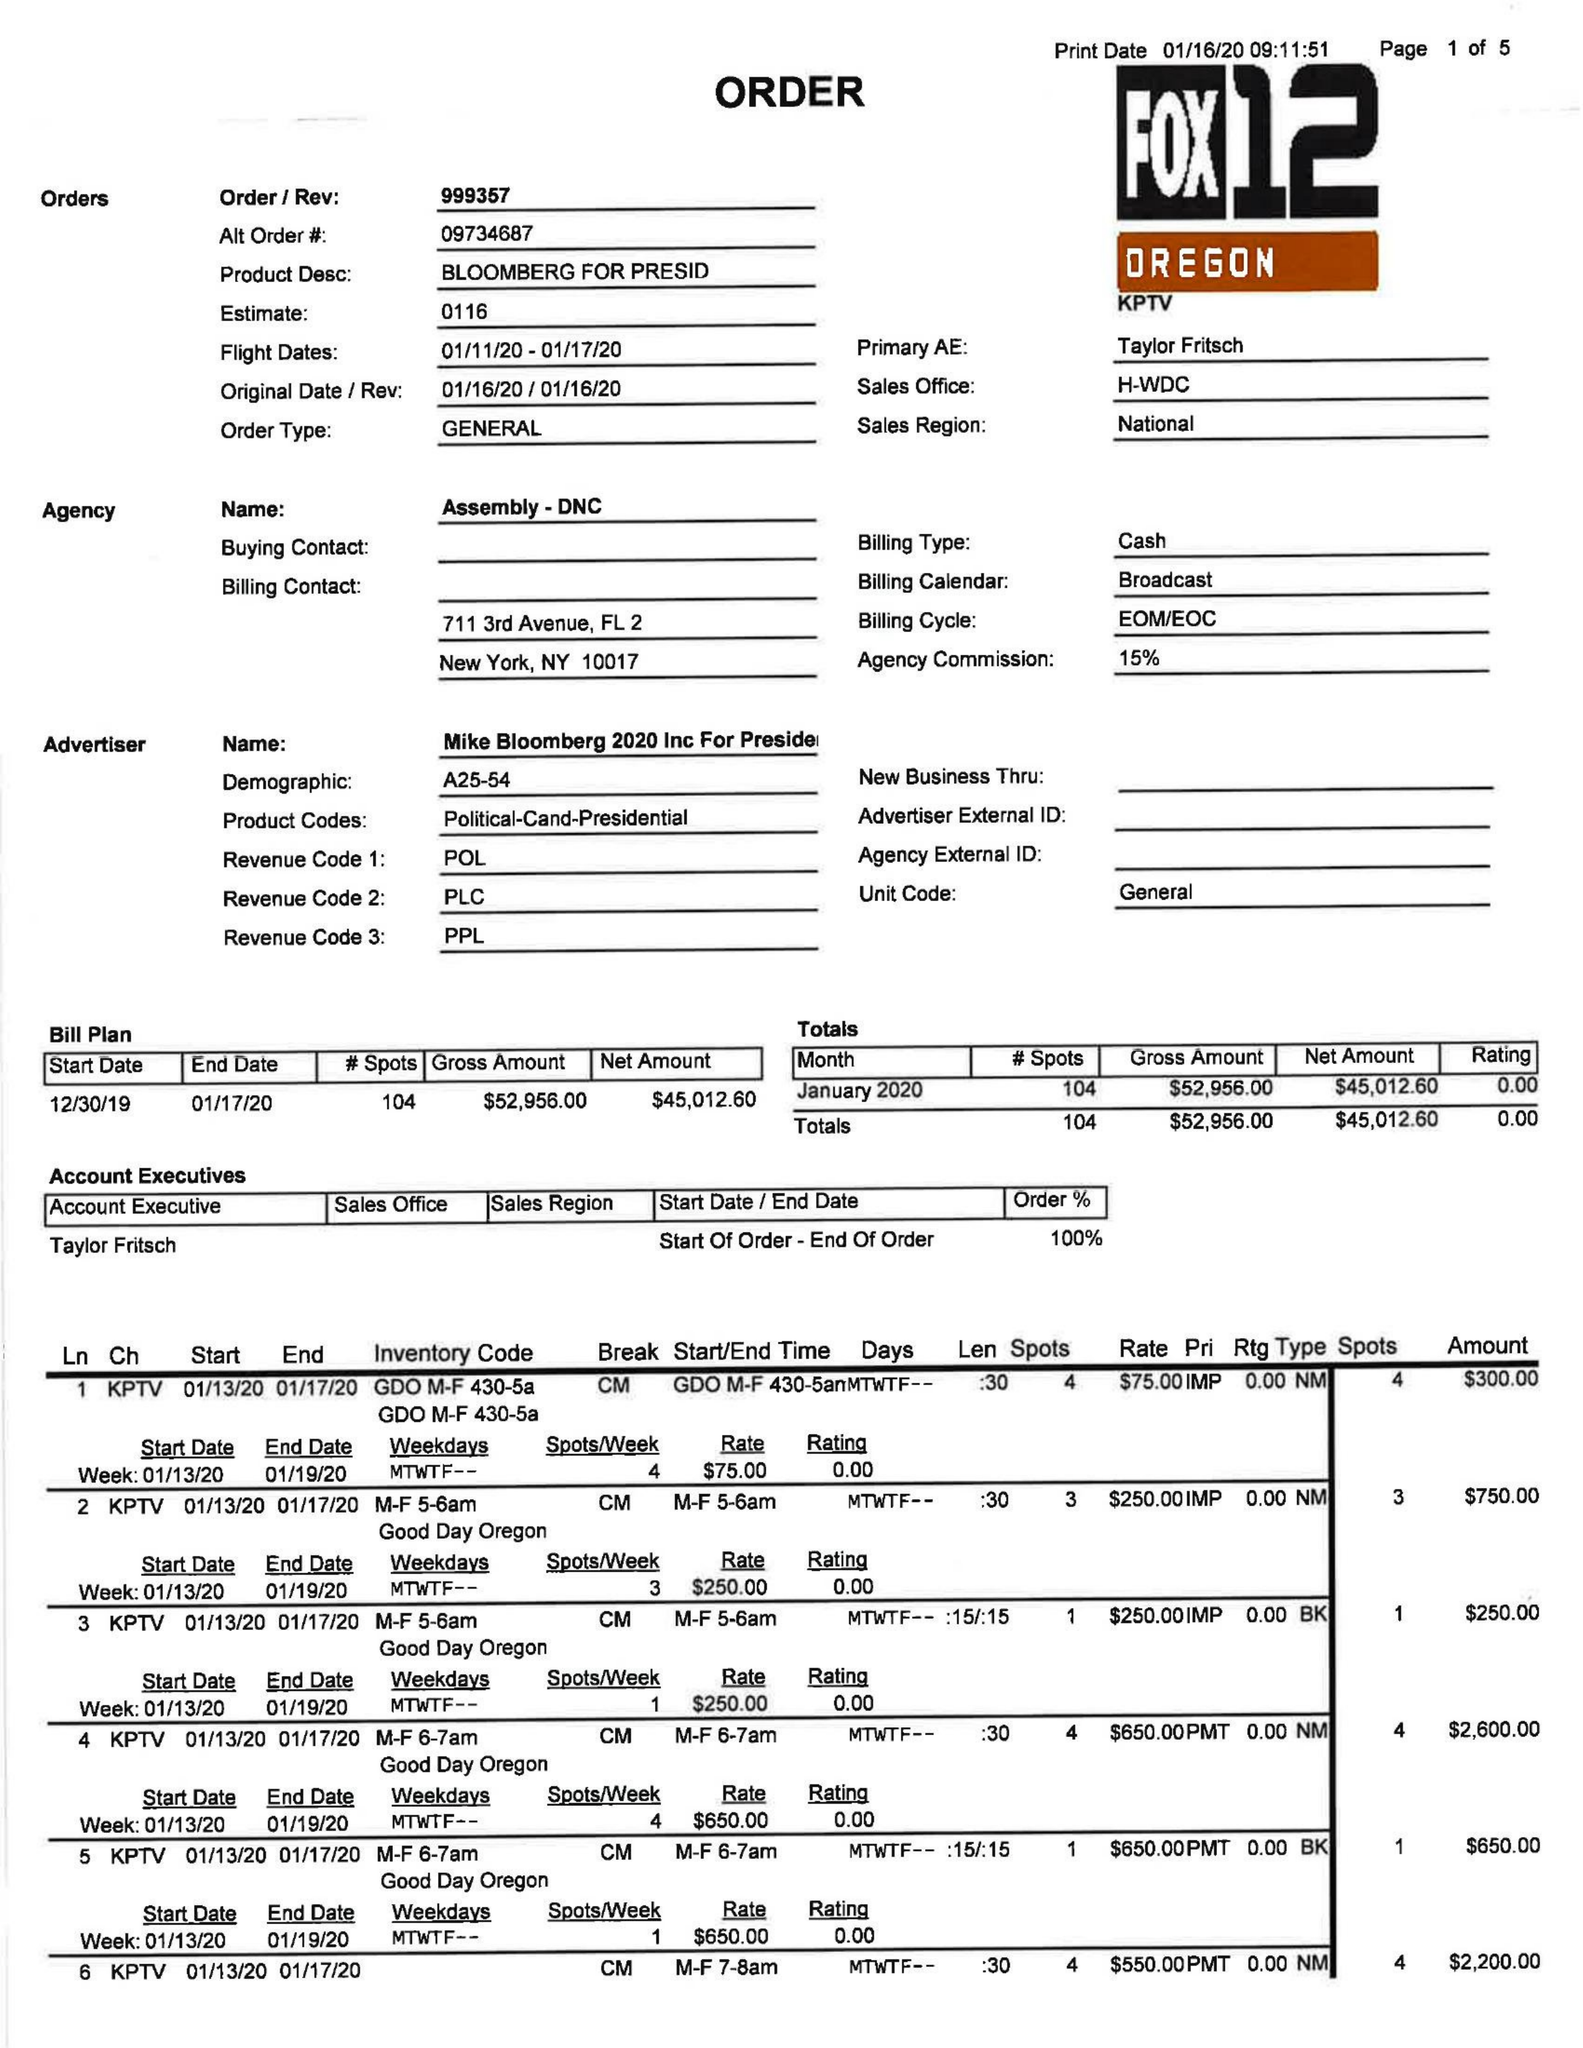What is the value for the contract_num?
Answer the question using a single word or phrase. 999357 